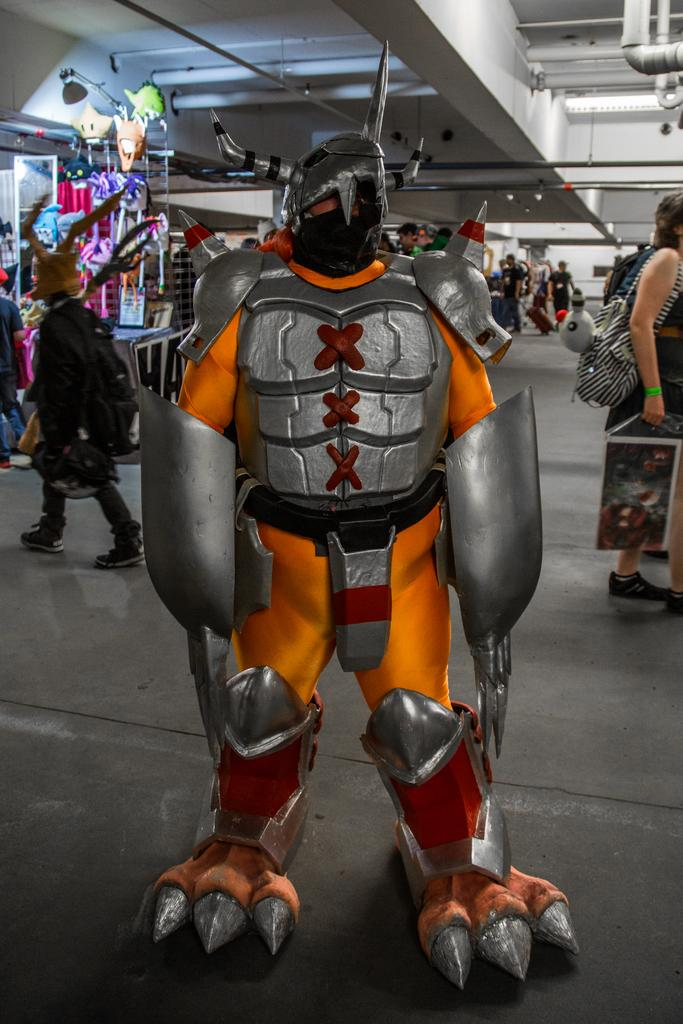What is the main subject in the center of the image? There is a robot in the center of the image. Who or what else is present in the image? There are people in the image. What can be seen in the background of the image? There is a wall and pipes visible in the background of the image. Where are the toys located in the image? The toys are placed on a table on the left side of the image. How many cattle can be seen grazing in the image? There are no cattle present in the image. Is there a door visible in the image? No, there is no door visible in the image. 